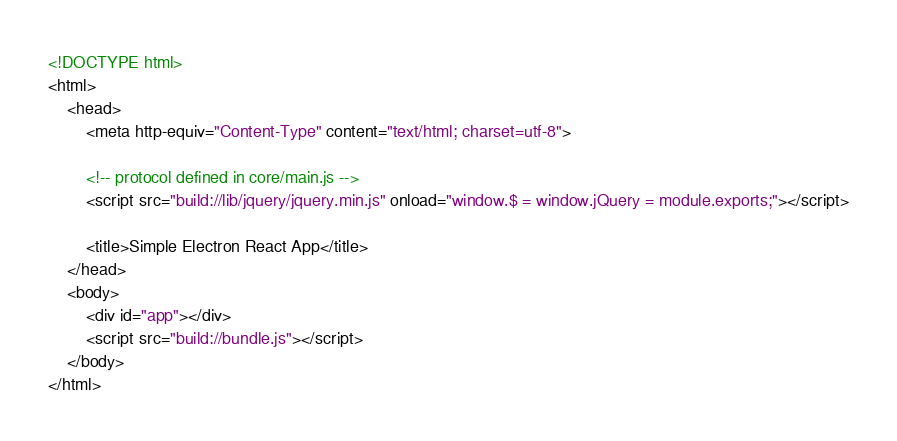<code> <loc_0><loc_0><loc_500><loc_500><_HTML_><!DOCTYPE html>
<html>
	<head>
		<meta http-equiv="Content-Type" content="text/html; charset=utf-8">

		<!-- protocol defined in core/main.js -->
		<script src="build://lib/jquery/jquery.min.js" onload="window.$ = window.jQuery = module.exports;"></script>

		<title>Simple Electron React App</title>
	</head>
	<body>
		<div id="app"></div>
		<script src="build://bundle.js"></script>
	</body>
</html>
</code> 